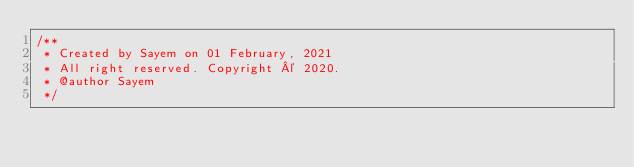Convert code to text. <code><loc_0><loc_0><loc_500><loc_500><_JavaScript_>/**
 * Created by Sayem on 01 February, 2021
 * All right reserved. Copyright © 2020.
 * @author Sayem
 */
</code> 